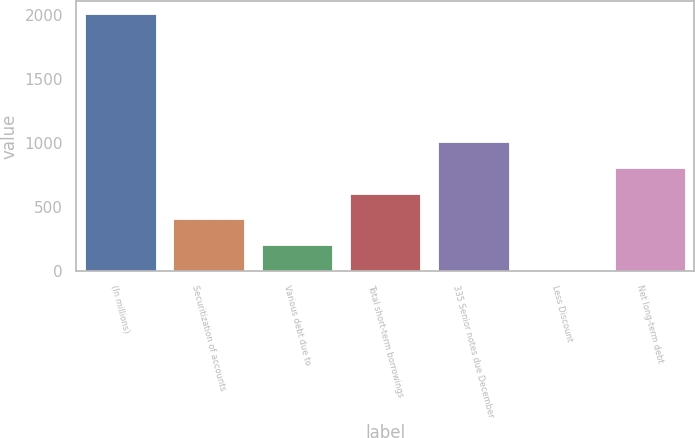Convert chart. <chart><loc_0><loc_0><loc_500><loc_500><bar_chart><fcel>(In millions)<fcel>Securitization of accounts<fcel>Various debt due to<fcel>Total short-term borrowings<fcel>335 Senior notes due December<fcel>Less Discount<fcel>Net long-term debt<nl><fcel>2010<fcel>402.24<fcel>201.27<fcel>603.21<fcel>1005.15<fcel>0.3<fcel>804.18<nl></chart> 